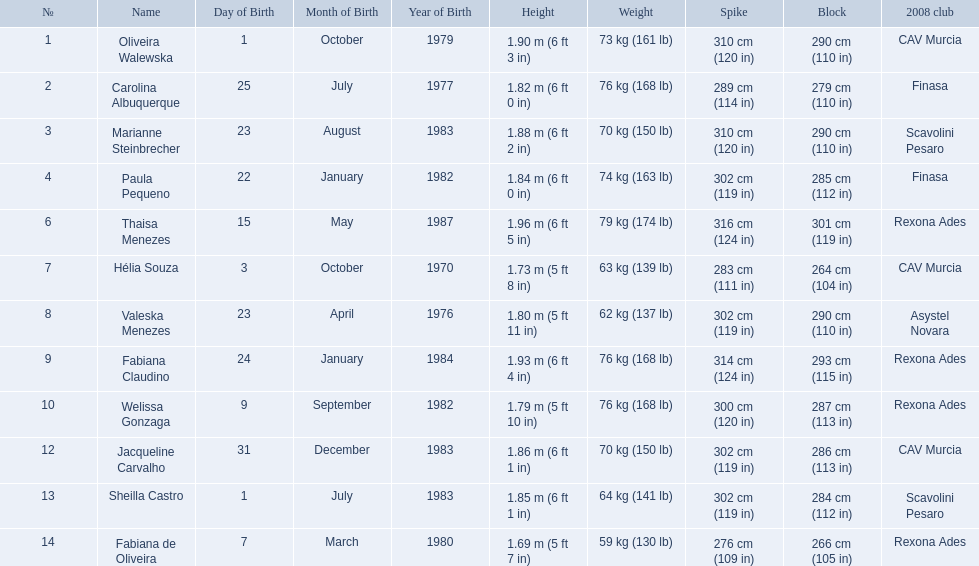Who played during the brazil at the 2008 summer olympics event? Oliveira Walewska, Carolina Albuquerque, Marianne Steinbrecher, Paula Pequeno, Thaisa Menezes, Hélia Souza, Valeska Menezes, Fabiana Claudino, Welissa Gonzaga, Jacqueline Carvalho, Sheilla Castro, Fabiana de Oliveira. And what was the recorded height of each player? 1.90 m (6 ft 3 in), 1.82 m (6 ft 0 in), 1.88 m (6 ft 2 in), 1.84 m (6 ft 0 in), 1.96 m (6 ft 5 in), 1.73 m (5 ft 8 in), 1.80 m (5 ft 11 in), 1.93 m (6 ft 4 in), 1.79 m (5 ft 10 in), 1.86 m (6 ft 1 in), 1.85 m (6 ft 1 in), 1.69 m (5 ft 7 in). Of those, which player is the shortest? Fabiana de Oliveira. Who are the players for brazil at the 2008 summer olympics? Oliveira Walewska, Carolina Albuquerque, Marianne Steinbrecher, Paula Pequeno, Thaisa Menezes, Hélia Souza, Valeska Menezes, Fabiana Claudino, Welissa Gonzaga, Jacqueline Carvalho, Sheilla Castro, Fabiana de Oliveira. What are their heights? 1.90 m (6 ft 3 in), 1.82 m (6 ft 0 in), 1.88 m (6 ft 2 in), 1.84 m (6 ft 0 in), 1.96 m (6 ft 5 in), 1.73 m (5 ft 8 in), 1.80 m (5 ft 11 in), 1.93 m (6 ft 4 in), 1.79 m (5 ft 10 in), 1.86 m (6 ft 1 in), 1.85 m (6 ft 1 in), 1.69 m (5 ft 7 in). What is the shortest height? 1.69 m (5 ft 7 in). Which player is that? Fabiana de Oliveira. 